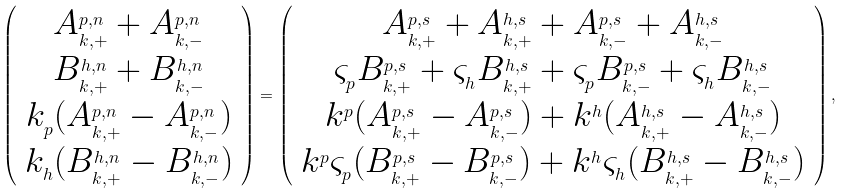<formula> <loc_0><loc_0><loc_500><loc_500>\left ( \begin{array} { c } A _ { _ { k , + } } ^ { _ { p , n } } + A _ { _ { k , - } } ^ { _ { p , n } } \\ B _ { _ { k , + } } ^ { _ { h , n } } + B _ { _ { k , - } } ^ { _ { h , n } } \\ k _ { _ { p } } ( A _ { _ { k , + } } ^ { _ { p , n } } - A _ { _ { k , - } } ^ { _ { p , n } } ) \\ k _ { _ { h } } ( B _ { _ { k , + } } ^ { _ { h , n } } - B _ { _ { k , - } } ^ { _ { h , n } } ) \end{array} \right ) = \left ( \begin{array} { c } A _ { _ { k , + } } ^ { _ { p , s } } + A _ { _ { k , + } } ^ { _ { h , s } } + A _ { _ { k , - } } ^ { _ { p , s } } + A _ { _ { k , - } } ^ { _ { h , s } } \\ \varsigma _ { _ { p } } B _ { _ { k , + } } ^ { _ { p , s } } + \varsigma _ { _ { h } } B _ { _ { k , + } } ^ { _ { h , s } } + \varsigma _ { _ { p } } B _ { _ { k , - } } ^ { _ { p , s } } + \varsigma _ { _ { h } } B _ { _ { k , - } } ^ { _ { h , s } } \\ k ^ { _ { p } } ( A _ { _ { k , + } } ^ { _ { p , s } } - A _ { _ { k , - } } ^ { _ { p , s } } ) + k ^ { _ { h } } ( A _ { _ { k , + } } ^ { _ { h , s } } - A _ { _ { k , - } } ^ { _ { h , s } } ) \\ k ^ { _ { p } } \varsigma _ { _ { p } } ( B _ { _ { k , + } } ^ { _ { p , s } } - B _ { _ { k , - } } ^ { _ { p , s } } ) + k ^ { _ { h } } \varsigma _ { _ { h } } ( B _ { _ { k , + } } ^ { _ { h , s } } - B _ { _ { k , - } } ^ { _ { h , s } } ) \end{array} \right ) ,</formula> 